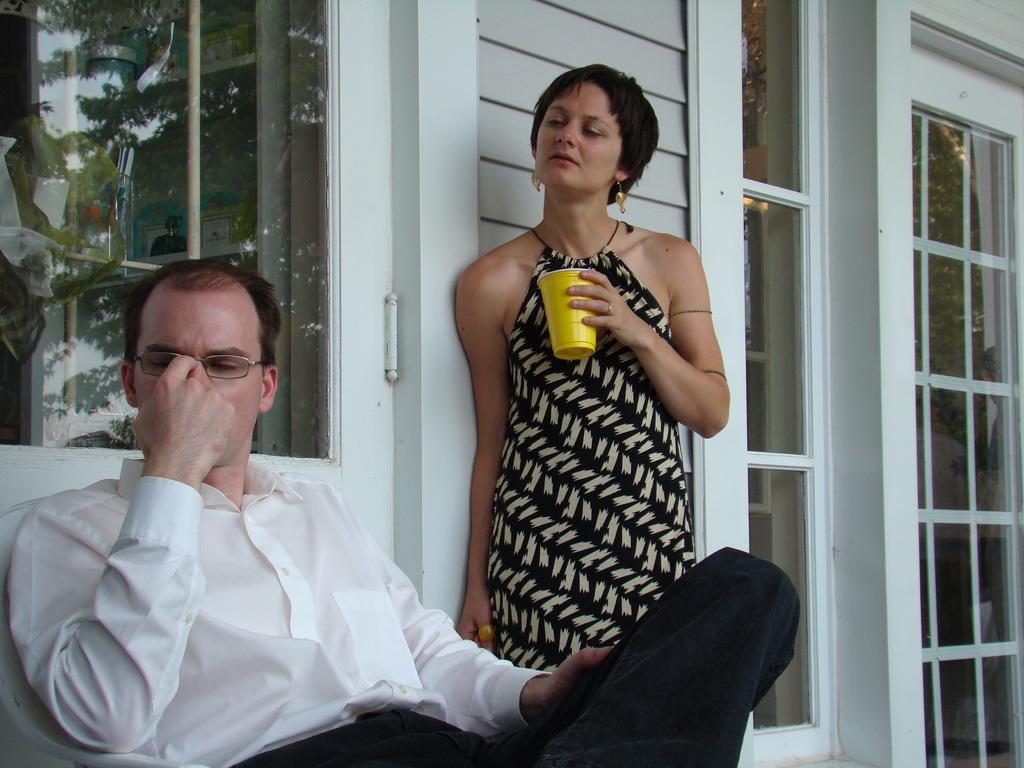In one or two sentences, can you explain what this image depicts? In this image we can see a male person wearing white color shirt, black color jeans and female person wearing black color dress, male person sitting on a chair, female person standing and leaning to the wall holding some coffee glass in he hands which is of gold color and in the background of the image there is a wall and glass doors. 